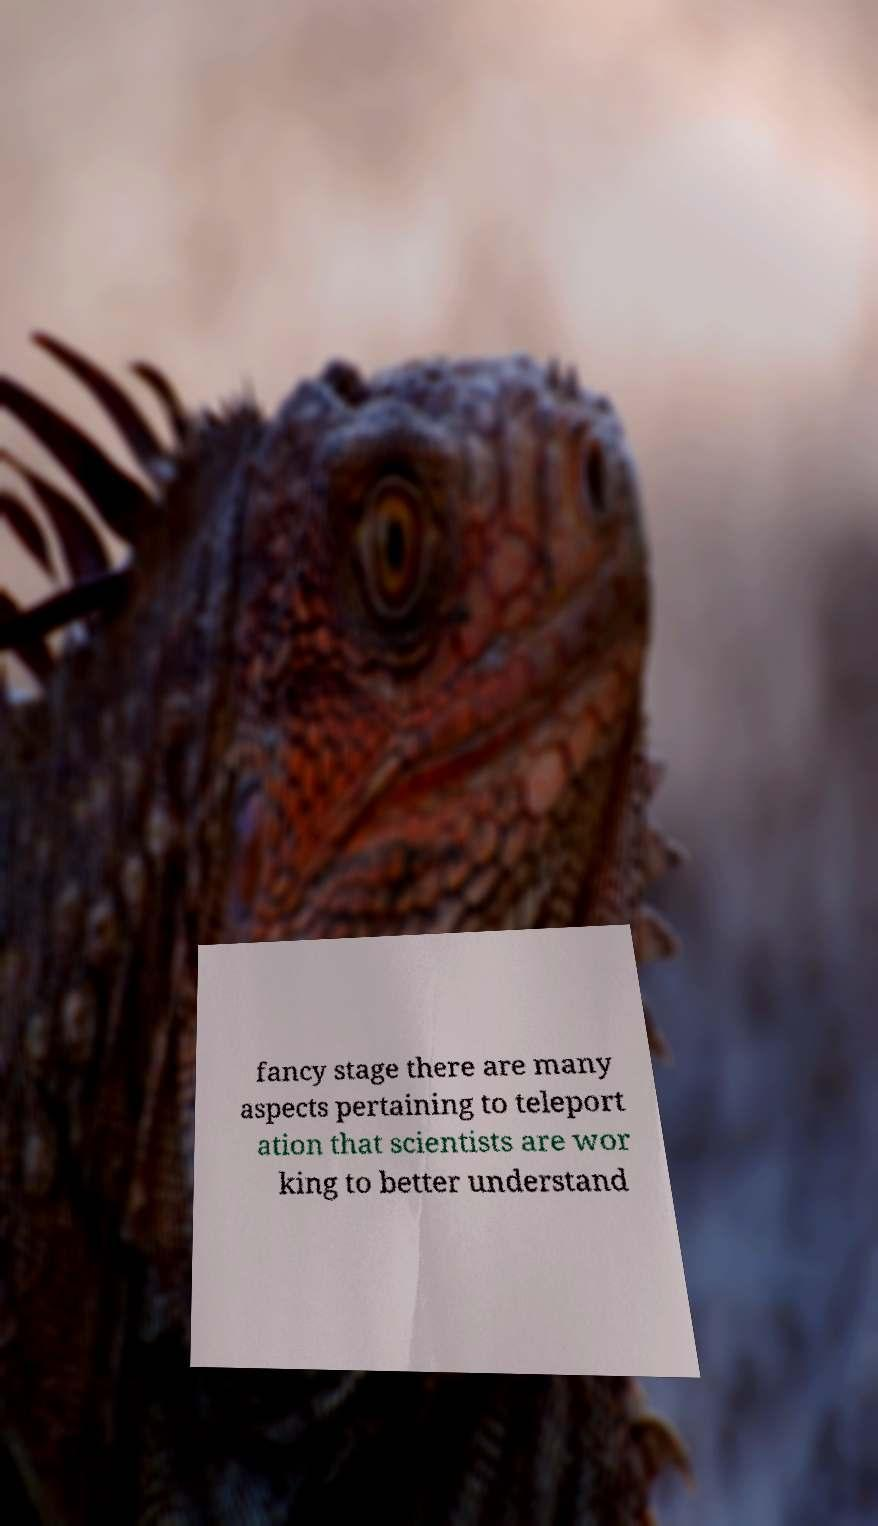Can you read and provide the text displayed in the image?This photo seems to have some interesting text. Can you extract and type it out for me? fancy stage there are many aspects pertaining to teleport ation that scientists are wor king to better understand 